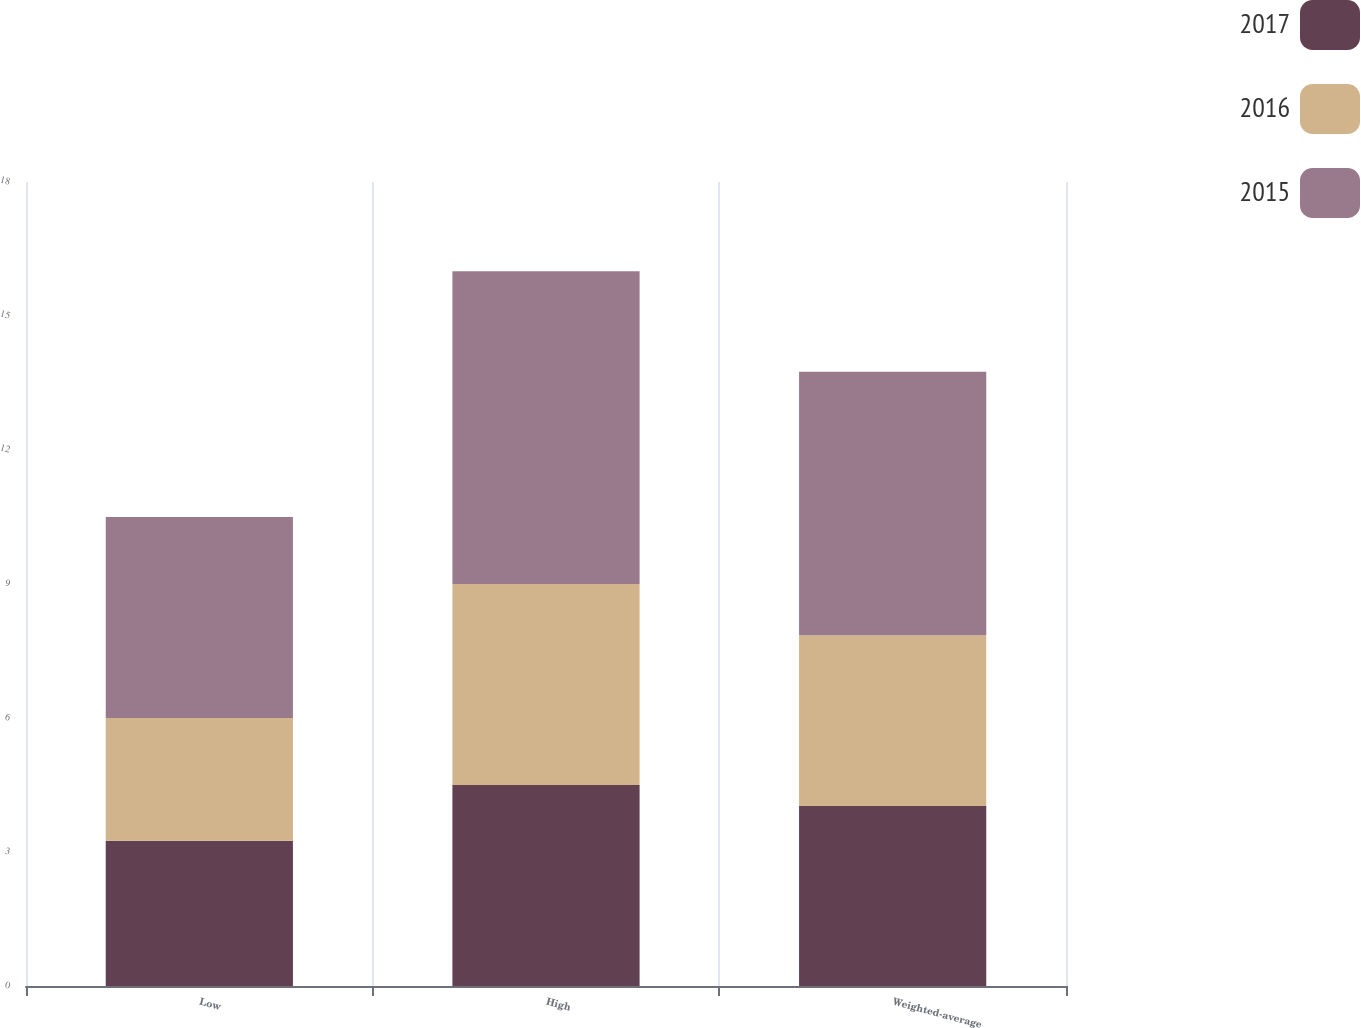<chart> <loc_0><loc_0><loc_500><loc_500><stacked_bar_chart><ecel><fcel>Low<fcel>High<fcel>Weighted-average<nl><fcel>2017<fcel>3.25<fcel>4.5<fcel>4.03<nl><fcel>2016<fcel>2.75<fcel>4.5<fcel>3.82<nl><fcel>2015<fcel>4.5<fcel>7<fcel>5.9<nl></chart> 